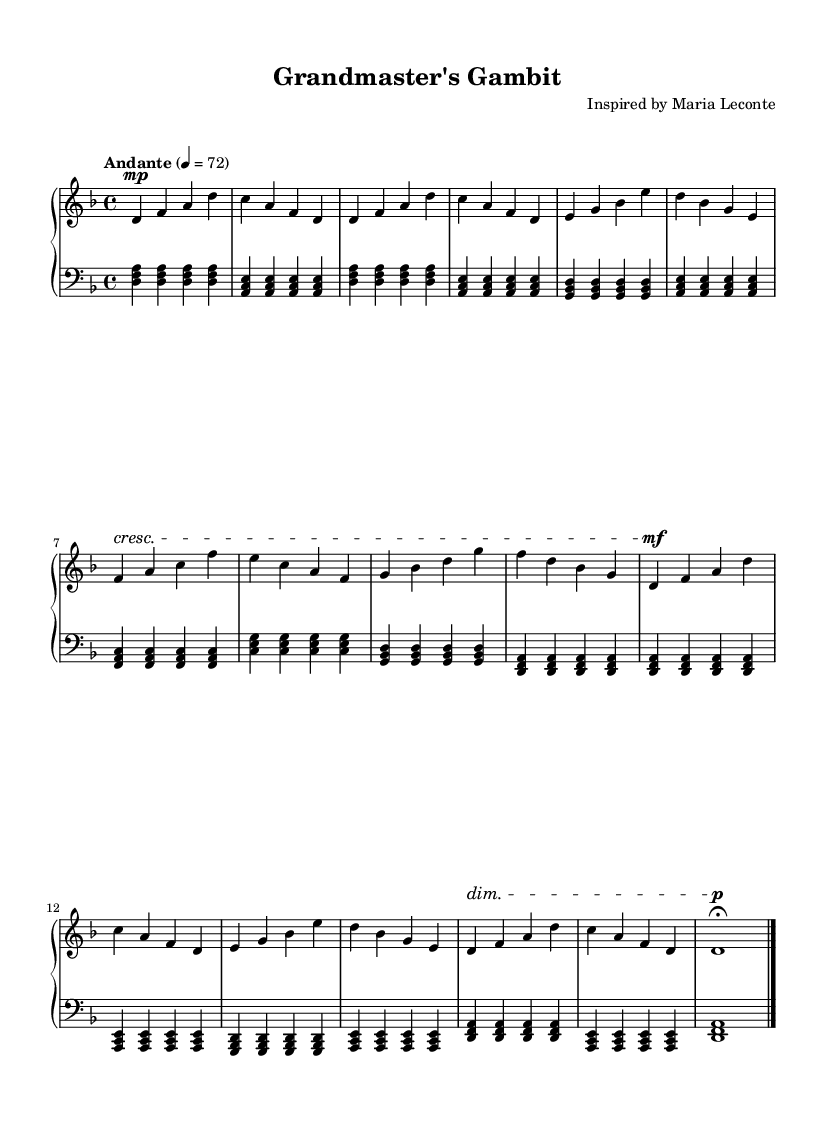What is the key signature of this music? The key signature is D minor, which has one flat (B flat).
Answer: D minor What is the time signature of this piece? The time signature shown in the music sheet is 4/4, indicating four beats per measure.
Answer: 4/4 What is the tempo marking for this piece? The tempo marking is "Andante," which typically means a moderate pace.
Answer: Andante What dynamic marking is used at the beginning of the B section? The dynamic marking indicating a crescendo is used at the beginning of the B section, which signals to increase the volume gradually.
Answer: Crescendo How many measures are in the B section of the piece? The B section consists of four measures, following the structured form of the music.
Answer: 4 What is the rhythmic value of the left-hand chord in the Intro section? The left-hand chord in the Intro section is held as a quarter note.
Answer: Quarter note What is the effect of the diminuendo at the end of the piece? The diminuendo signifies a gradual decrease in volume, creating a soft, reflective end to the piece, often used to enhance the contemplative mood.
Answer: Diminuendo 